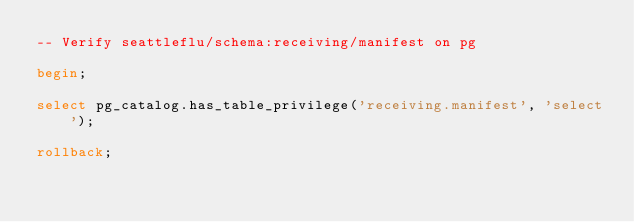Convert code to text. <code><loc_0><loc_0><loc_500><loc_500><_SQL_>-- Verify seattleflu/schema:receiving/manifest on pg

begin;

select pg_catalog.has_table_privilege('receiving.manifest', 'select');

rollback;
</code> 